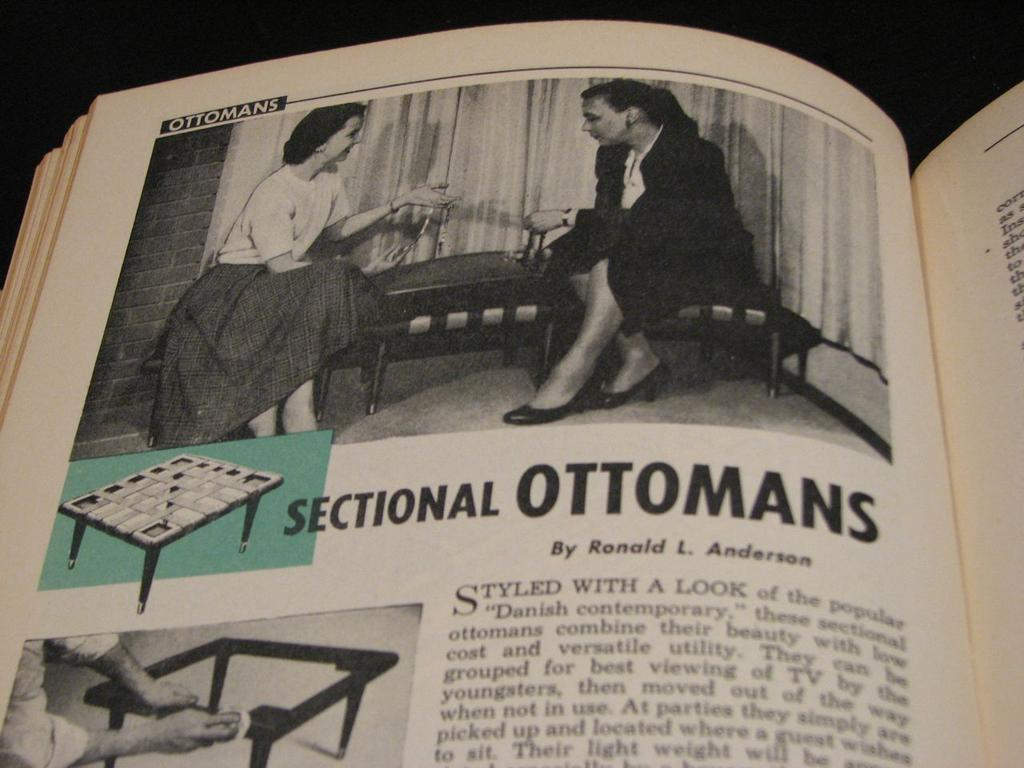What is the main object in the image? There is a book in the image. Can you read the title of the book? The book has the title "Sectional Ottomans by Ronald L. Anderson." What type of hand can be seen holding the book in the image? There is no hand visible in the image; it only shows the book with the title "Sectional Ottomans by Ronald L. Anderson." 